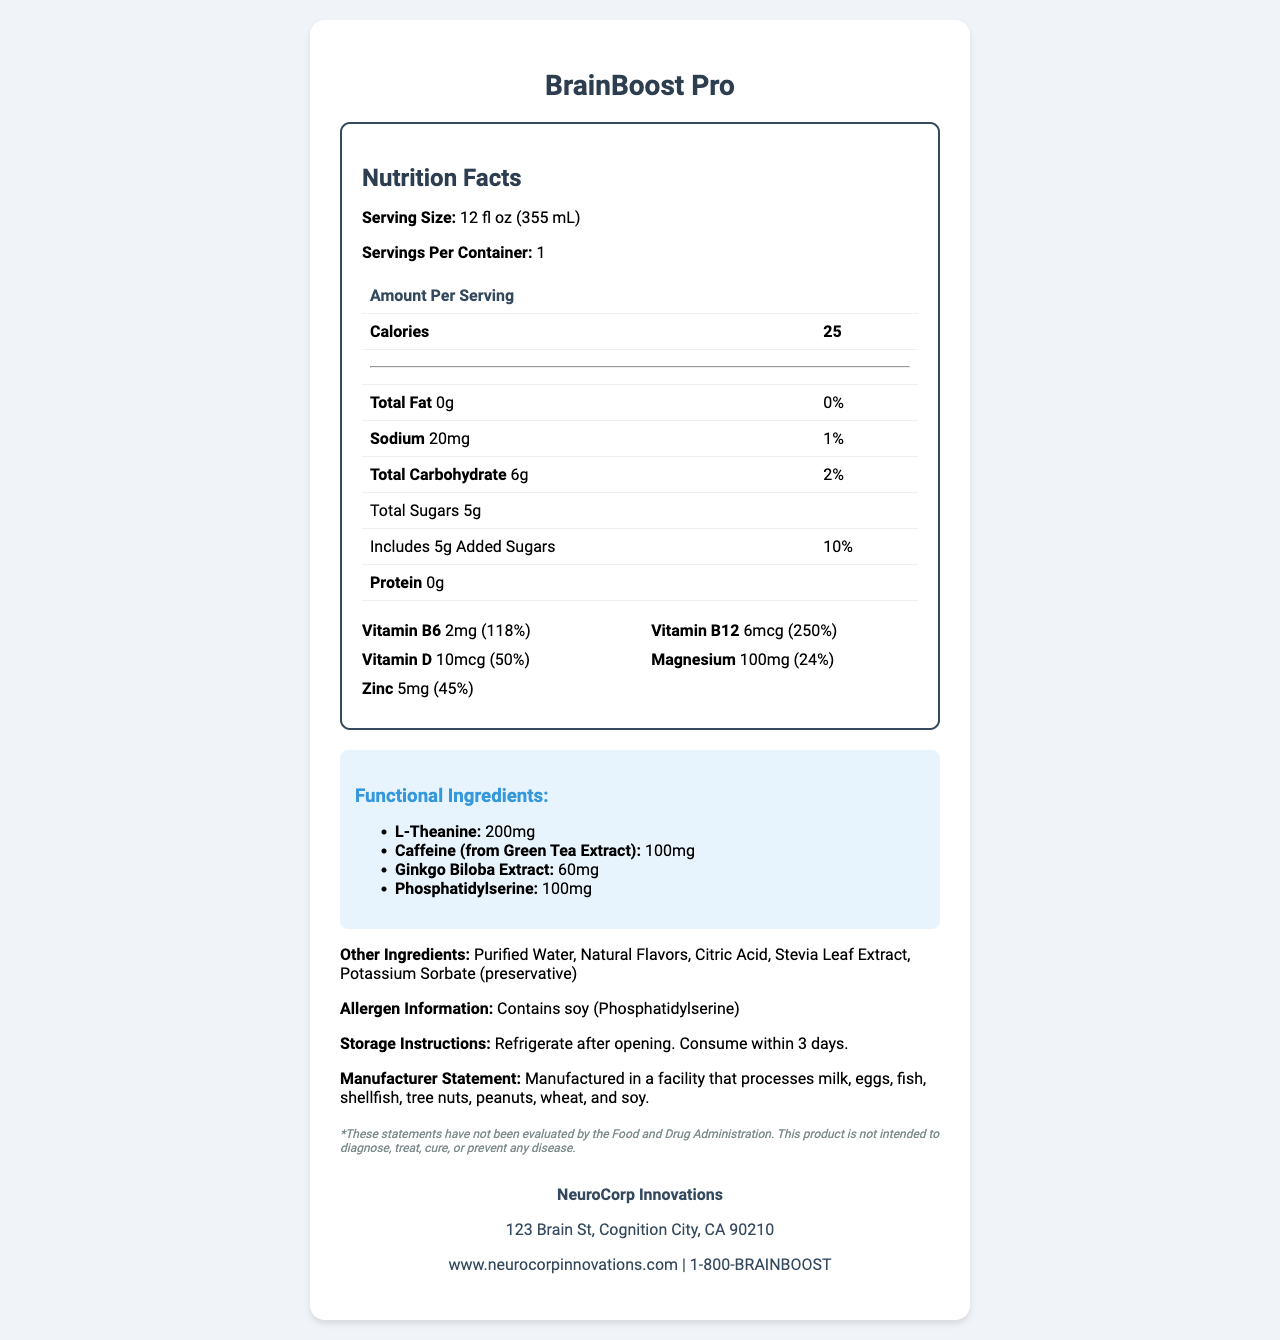who is the manufacturer of BrainBoost Pro? According to the company information section at the bottom of the document, NeuroCorp Innovations is the manufacturer.
Answer: NeuroCorp Innovations what is the serving size of BrainBoost Pro? The serving size is clearly mentioned at the top of the Nutrition Facts as "Serving Size: 12 fl oz (355 mL)".
Answer: 12 fl oz (355 mL) how many calories are in one serving of BrainBoost Pro? The calories per serving are listed in the table under the Nutrition Facts heading as 25.
Answer: 25 which vitamin has the highest daily value percentage in BrainBoost Pro? According to the vitamins and minerals section, Vitamin B12 has the highest daily value percentage, which is 250%.
Answer: Vitamin B12 how much protein is in one serving of BrainBoost Pro? The protein amount per serving is indicated as 0g in the Nutrition Facts table.
Answer: 0g how much sodium is contained in one serving of BrainBoost Pro? A. 5mg B. 20mg C. 100mg The amount of sodium is listed in the Nutrition Facts table under the "Sodium" row, which shows 20mg.
Answer: B which of these ingredients is a functional ingredient in BrainBoost Pro? A. Stevia Leaf Extract B. L-Theanine C. Citric Acid D. Potassium Sorbate L-Theanine is listed as a functional ingredient, whereas the others like Stevia Leaf Extract, Citric Acid, and Potassium Sorbate are listed under other ingredients.
Answer: B does BrainBoost Pro contain any allergens? The allergen information section states that it contains soy (Phosphatidylserine).
Answer: Yes summarize the main idea of the document. The document provides a comprehensive overview of the nutritional and functional properties of BrainBoost Pro, highlighting its cognitive benefits and detailed nutritional content. It also includes important consumer information such as storage instructions, allergen details, and manufacturer information. Product claims are made about its cognitive enhancement benefits, albeit with a disclaimer regarding FDA evaluation.
Answer: BrainBoost Pro is a functional beverage designed to support cognitive performance. It contains vitamins, minerals, and other functional ingredients such as L-Theanine and Caffeine. The Nutrition Facts label provides detailed information about the nutritional content, including calories, vitamins, and minerals. The document also includes details on other ingredients, allergen information, storage instructions, manufacturer information, and product claims. what is the address of NeuroCorp Innovations? The company information section at the bottom of the document lists the address as 123 Brain St, Cognition City, CA 90210.
Answer: 123 Brain St, Cognition City, CA 90210 are the statements about the product's cognitive benefits evaluated by the FDA? The disclaimer at the bottom states that these statements have not been evaluated by the Food and Drug Administration (FDA).
Answer: No how should BrainBoost Pro be stored after opening? The storage instructions section clearly mentions that the product should be refrigerated after opening and consumed within 3 days.
Answer: Refrigerate after opening. Consume within 3 days. which ingredient provides caffeine in BrainBoost Pro? The functional ingredients section lists caffeine as being derived from Green Tea Extract.
Answer: Green Tea Extract what information about the manufacturing facility is provided? The manufacturer statement section mentions that the facility processes the listed allergens.
Answer: It processes milk, eggs, fish, shellfish, tree nuts, peanuts, wheat, and soy. how much Magnesium is present in one serving of BrainBoost Pro? The vitamins and minerals section states that there is 100mg of Magnesium per serving.
Answer: 100mg what other ingredients are included in BrainBoost Pro? The other ingredients section lists these ingredients.
Answer: Purified Water, Natural Flavors, Citric Acid, Stevia Leaf Extract, Potassium Sorbate (preservative) what is the contact number for NeuroCorp Innovations? The company information section at the bottom lists the contact number as 1-800-BRAINBOOST.
Answer: 1-800-BRAINBOOST how many servings are there in one container of BrainBoost Pro? The servings per container are listed as 1 in the Nutrition Facts section.
Answer: 1 why does BrainBoost Pro have added sugars? The document does not explain why added sugars are included in the product.
Answer: Not enough information 